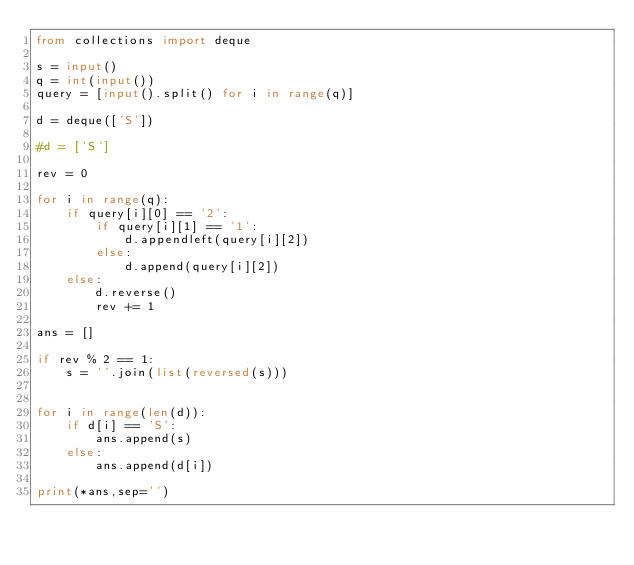<code> <loc_0><loc_0><loc_500><loc_500><_Python_>from collections import deque

s = input()
q = int(input())
query = [input().split() for i in range(q)]

d = deque(['S'])

#d = ['S']

rev = 0

for i in range(q):
    if query[i][0] == '2':
        if query[i][1] == '1':
            d.appendleft(query[i][2])
        else:
            d.append(query[i][2])
    else:
        d.reverse()
        rev += 1

ans = []

if rev % 2 == 1:
    s = ''.join(list(reversed(s)))


for i in range(len(d)):
    if d[i] == 'S':
        ans.append(s)
    else:
        ans.append(d[i])

print(*ans,sep='')</code> 